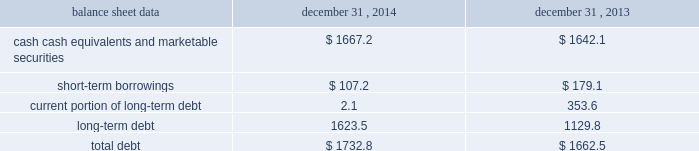Management 2019s discussion and analysis of financial condition and results of operations 2013 ( continued ) ( amounts in millions , except per share amounts ) net cash used in investing activities during 2013 primarily related to payments for capital expenditures and acquisitions .
Capital expenditures of $ 173.0 related primarily to computer hardware and software and leasehold improvements .
We made payments of $ 61.5 related to acquisitions completed during 2013 , net of cash acquired .
Financing activities net cash used in financing activities during 2014 primarily related to the purchase of long-term debt , the repurchase of our common stock and payment of dividends .
During 2014 , we redeemed all $ 350.0 in aggregate principal amount of the 6.25% ( 6.25 % ) notes , repurchased 14.9 shares of our common stock for an aggregate cost of $ 275.1 , including fees , and made dividend payments of $ 159.0 on our common stock .
This was offset by the issuance of $ 500.0 in aggregate principal amount of our 4.20% ( 4.20 % ) notes .
Net cash used in financing activities during 2013 primarily related to the purchase of long-term debt , the repurchase of our common stock and payment of dividends .
We redeemed all $ 600.0 in aggregate principal amount of our 10.00% ( 10.00 % ) notes .
In addition , we repurchased 31.8 shares of our common stock for an aggregate cost of $ 481.8 , including fees , and made dividend payments of $ 126.0 on our common stock .
Foreign exchange rate changes the effect of foreign exchange rate changes on cash and cash equivalents included in the consolidated statements of cash flows resulted in a decrease of $ 101.0 in 2014 .
The decrease was primarily a result of the u.s .
Dollar being stronger than several foreign currencies , including the canadian dollar , brazilian real , australian dollar and the euro as of december 31 , 2014 compared to december 31 , 2013 .
The effect of foreign exchange rate changes on cash and cash equivalents included in the consolidated statements of cash flows resulted in a decrease of $ 94.1 in 2013 .
The decrease was primarily a result of the u.s .
Dollar being stronger than several foreign currencies , including the australian dollar , brazilian real , canadian dollar , japanese yen , and south african rand as of december 31 , 2013 compared to december 31 , 2012. .
Liquidity outlook we expect our cash flow from operations , cash and cash equivalents to be sufficient to meet our anticipated operating requirements at a minimum for the next twelve months .
We also have a committed corporate credit facility as well as uncommitted facilities available to support our operating needs .
We continue to maintain a disciplined approach to managing liquidity , with flexibility over significant uses of cash , including our capital expenditures , cash used for new acquisitions , our common stock repurchase program and our common stock dividends .
From time to time , we evaluate market conditions and financing alternatives for opportunities to raise additional funds or otherwise improve our liquidity profile , enhance our financial flexibility and manage market risk .
Our ability to access the capital markets depends on a number of factors , which include those specific to us , such as our credit rating , and those related to the financial markets , such as the amount or terms of available credit .
There can be no guarantee that we would be able to access new sources of liquidity on commercially reasonable terms , or at all. .
What was the average of short-term borrowings in 2013-2014? 
Computations: ((107.2 + 179.1) / 2)
Answer: 143.15. 